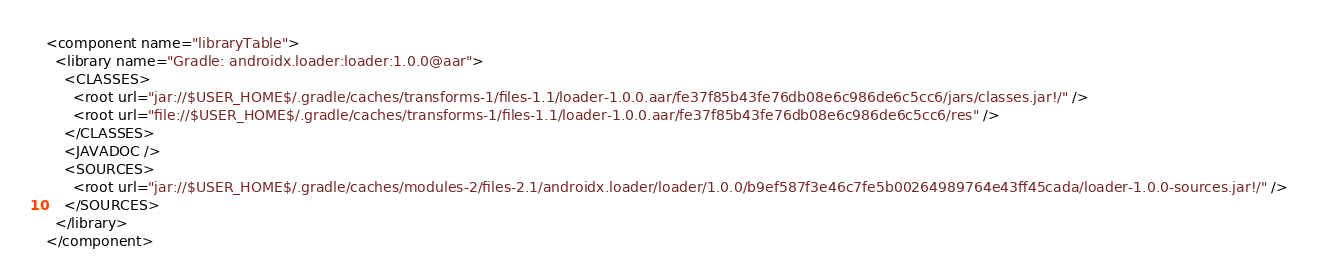<code> <loc_0><loc_0><loc_500><loc_500><_XML_><component name="libraryTable">
  <library name="Gradle: androidx.loader:loader:1.0.0@aar">
    <CLASSES>
      <root url="jar://$USER_HOME$/.gradle/caches/transforms-1/files-1.1/loader-1.0.0.aar/fe37f85b43fe76db08e6c986de6c5cc6/jars/classes.jar!/" />
      <root url="file://$USER_HOME$/.gradle/caches/transforms-1/files-1.1/loader-1.0.0.aar/fe37f85b43fe76db08e6c986de6c5cc6/res" />
    </CLASSES>
    <JAVADOC />
    <SOURCES>
      <root url="jar://$USER_HOME$/.gradle/caches/modules-2/files-2.1/androidx.loader/loader/1.0.0/b9ef587f3e46c7fe5b00264989764e43ff45cada/loader-1.0.0-sources.jar!/" />
    </SOURCES>
  </library>
</component></code> 